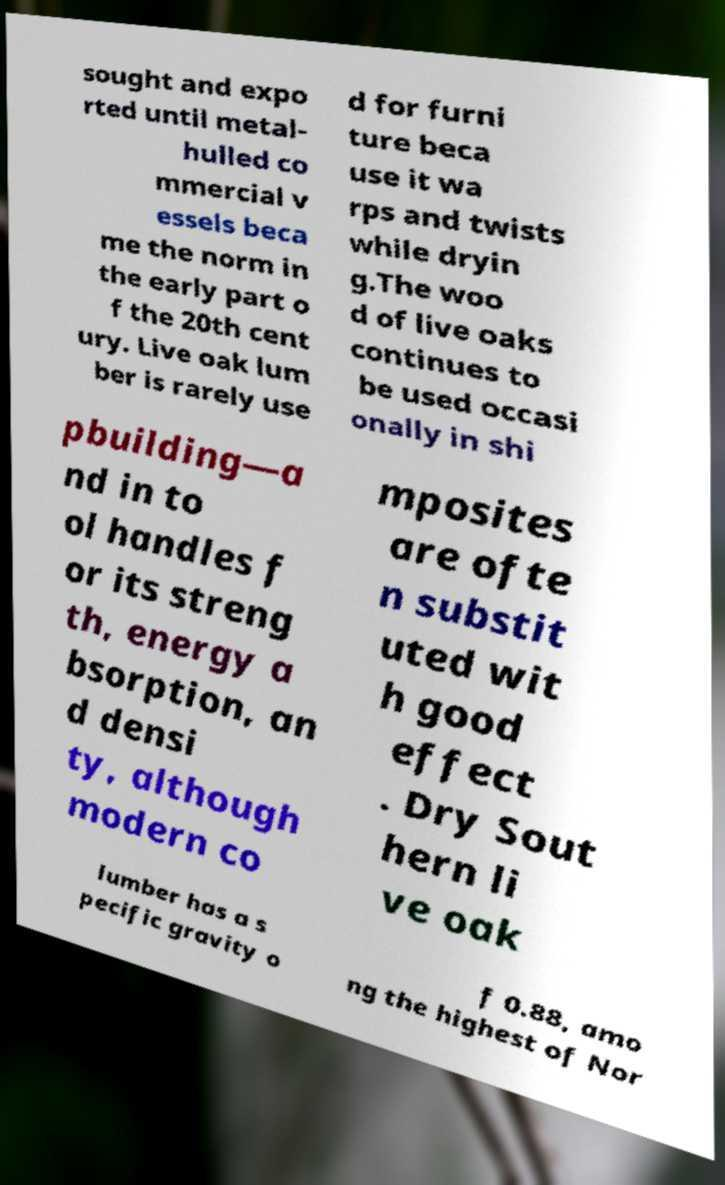For documentation purposes, I need the text within this image transcribed. Could you provide that? sought and expo rted until metal- hulled co mmercial v essels beca me the norm in the early part o f the 20th cent ury. Live oak lum ber is rarely use d for furni ture beca use it wa rps and twists while dryin g.The woo d of live oaks continues to be used occasi onally in shi pbuilding—a nd in to ol handles f or its streng th, energy a bsorption, an d densi ty, although modern co mposites are ofte n substit uted wit h good effect . Dry Sout hern li ve oak lumber has a s pecific gravity o f 0.88, amo ng the highest of Nor 